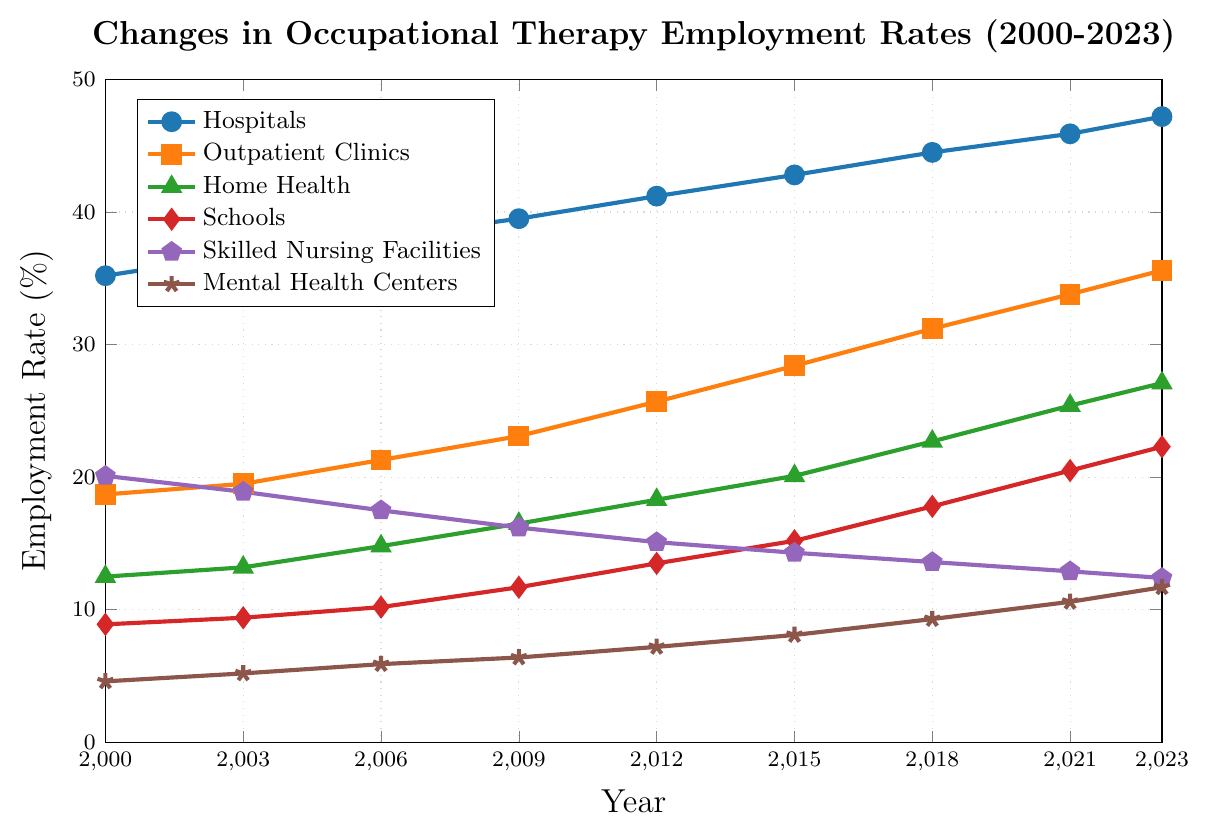What is the trend in employment rates for hospitals from 2000 to 2023? Observe the data points related to hospitals' employment rates over the years. The trend shows a continuous increase from 35.2% in 2000 to 47.2% in 2023.
Answer: Increasing Which healthcare setting had the highest employment rate in 2015? Compare the employment rates of all healthcare settings for the year 2015. Hospitals have the highest employment rate at 42.8%.
Answer: Hospitals How has the employment rate for mental health centers changed from 2000 to 2023? Look at the data points for mental health centers for the years 2000 and 2023. The rate increased from 4.6% in 2000 to 11.7% in 2023.
Answer: Increased Which setting had a decrease in employment rate over the years shown? Analyze the trends for all settings. Only Skilled Nursing Facilities show a decrease going from 20.1% in 2000 to 12.4% in 2023.
Answer: Skilled Nursing Facilities What is the employment rate difference between hospitals and outpatient clinics in 2023? Subtract the employment rate of outpatient clinics (35.6%) from hospitals (47.2%) in 2023.
Answer: 11.6% Which healthcare setting showed the most significant increase in employment rate over the entire period? Calculate the increase for each setting from 2000 to 2023. Hospitals increased by 12.0%, Outpatient Clinics by 16.9%, Home Health by 14.6%, Schools by 13.4%, Skilled Nursing Facilities decreased by 7.7%, and Mental Health Centers increased by 7.1%. Outpatient Clinics had the most significant increase.
Answer: Outpatient Clinics How did the employment rates for schools change between 2018 and 2023? Observe the data points for schools in 2018 and 2023. The rate increased from 17.8% to 22.3%.
Answer: Increased What is the difference between the highest and the lowest employment rates in 2021? Identify the highest (Hospitals at 45.9%) and lowest (Mental Health Centers at 10.6%) rates in 2021 and subtract them.
Answer: 35.3% Which two settings had the closest employment rates in 2023? Compare employment rates for all settings in 2023. Schools (22.3%) and Home Health (27.1%) are the closest with a difference of 4.8%.
Answer: Schools and Home Health What was the employment rate for outpatient clinics in 2009? Identify the data point for outpatient clinics in the year 2009. It is 23.1%.
Answer: 23.1% 